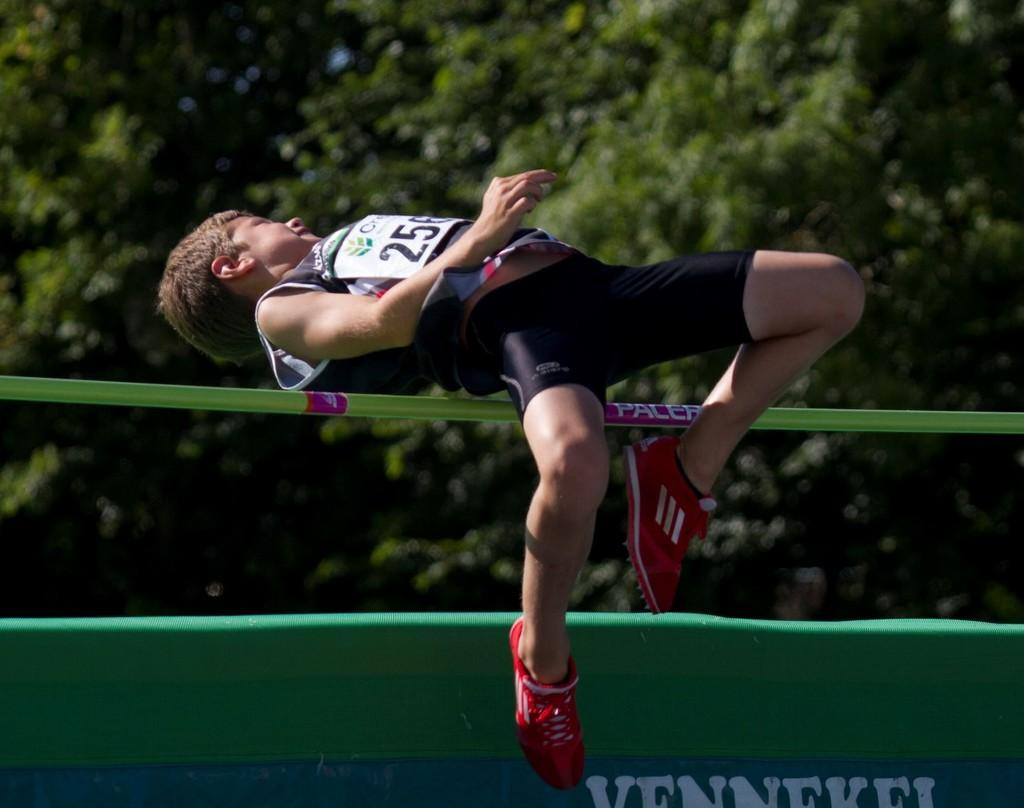Who or what is the main subject in the image? There is a person in the image. What is the person doing in the image? The person is jumping in the air. What can be seen in the background of the image? There are trees in the background of the image. What type of drug can be seen in the person's hand in the image? There is no drug present in the image; the person is simply jumping in the air. 